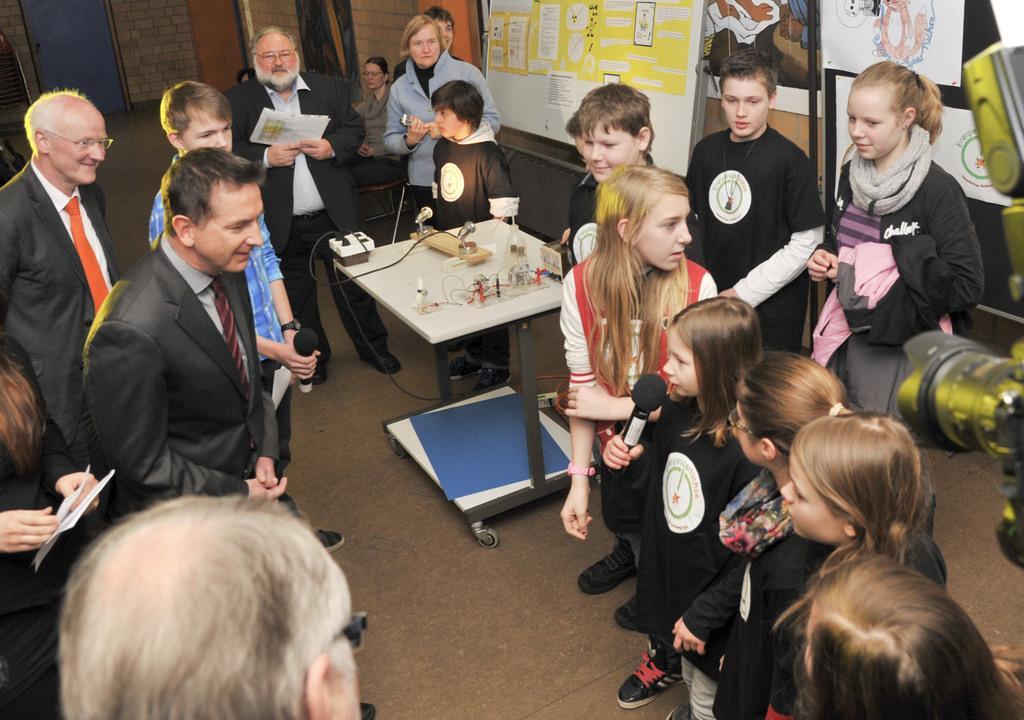How would you summarize this image in a sentence or two? In this picture we can see a group of people standing where one girl is holding mic in her hand and talking and some are holding papers in their hands and here on table we can see wires and in background we can see wall with posters. 